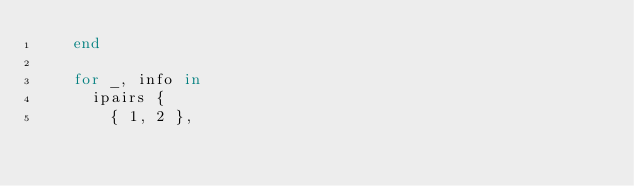<code> <loc_0><loc_0><loc_500><loc_500><_Lua_>    end

    for _, info in
      ipairs {
        { 1, 2 },</code> 